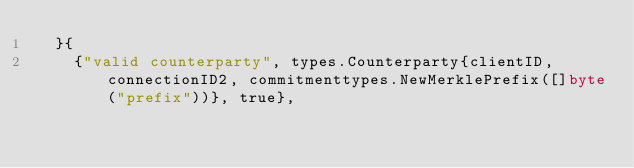<code> <loc_0><loc_0><loc_500><loc_500><_Go_>	}{
		{"valid counterparty", types.Counterparty{clientID, connectionID2, commitmenttypes.NewMerklePrefix([]byte("prefix"))}, true},</code> 